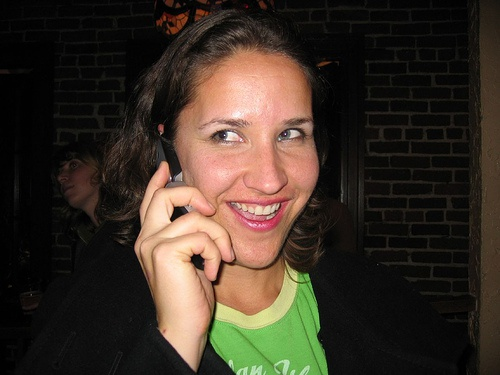Describe the objects in this image and their specific colors. I can see people in black and salmon tones, people in black, maroon, and gray tones, and cell phone in black, brown, and salmon tones in this image. 